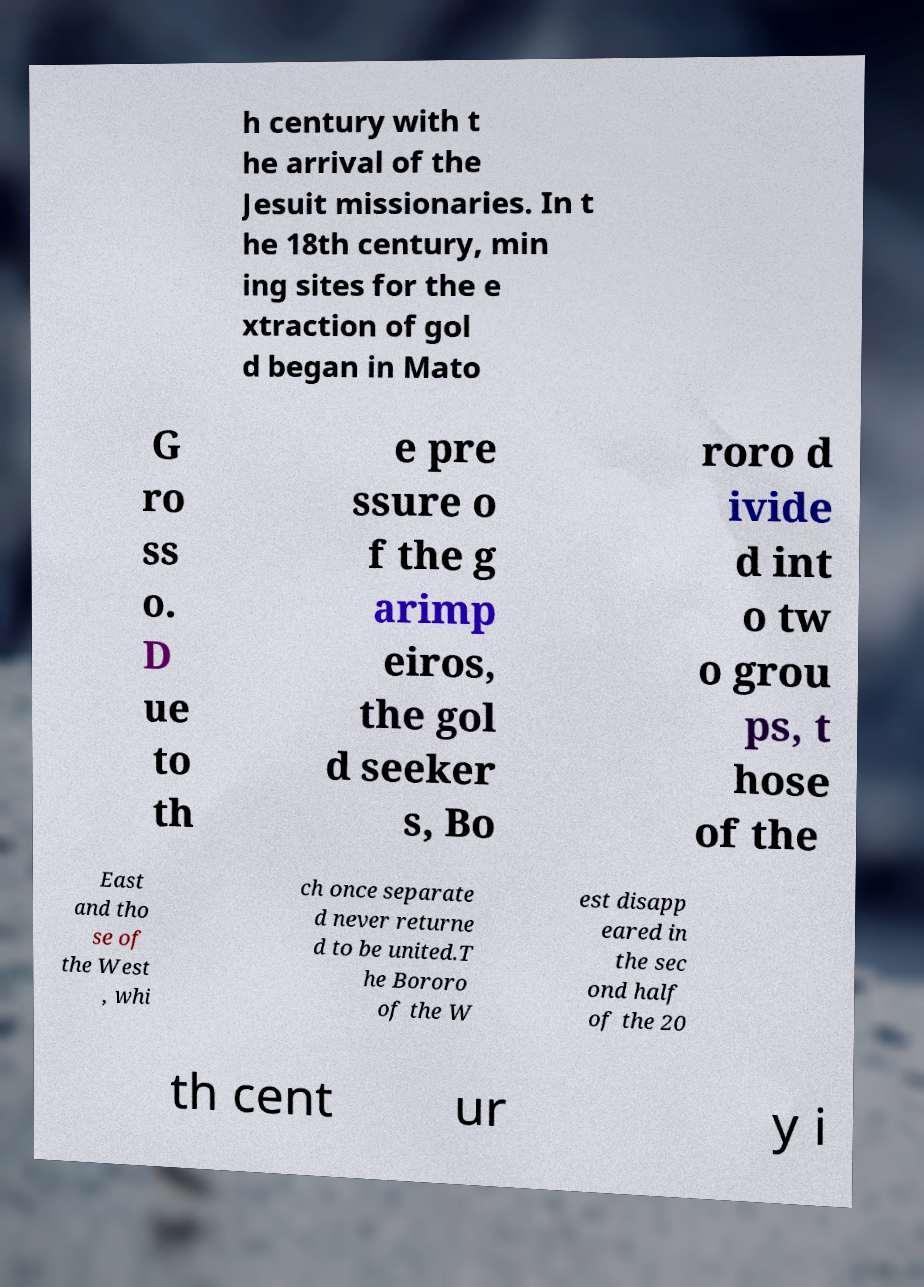Could you extract and type out the text from this image? h century with t he arrival of the Jesuit missionaries. In t he 18th century, min ing sites for the e xtraction of gol d began in Mato G ro ss o. D ue to th e pre ssure o f the g arimp eiros, the gol d seeker s, Bo roro d ivide d int o tw o grou ps, t hose of the East and tho se of the West , whi ch once separate d never returne d to be united.T he Bororo of the W est disapp eared in the sec ond half of the 20 th cent ur y i 